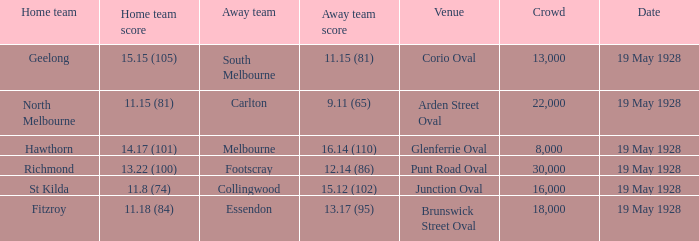What is the listed crowd when essendon is the away squad? 1.0. 